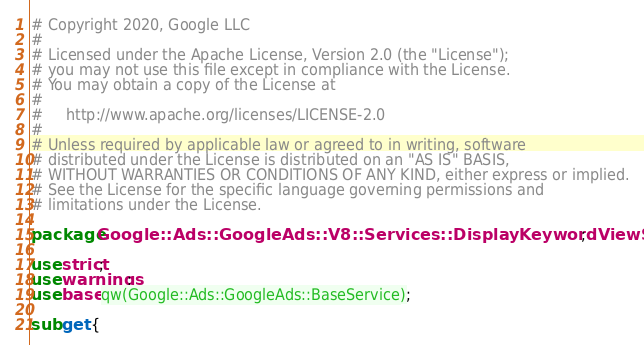<code> <loc_0><loc_0><loc_500><loc_500><_Perl_># Copyright 2020, Google LLC
#
# Licensed under the Apache License, Version 2.0 (the "License");
# you may not use this file except in compliance with the License.
# You may obtain a copy of the License at
#
#     http://www.apache.org/licenses/LICENSE-2.0
#
# Unless required by applicable law or agreed to in writing, software
# distributed under the License is distributed on an "AS IS" BASIS,
# WITHOUT WARRANTIES OR CONDITIONS OF ANY KIND, either express or implied.
# See the License for the specific language governing permissions and
# limitations under the License.

package Google::Ads::GoogleAds::V8::Services::DisplayKeywordViewService;

use strict;
use warnings;
use base qw(Google::Ads::GoogleAds::BaseService);

sub get {</code> 